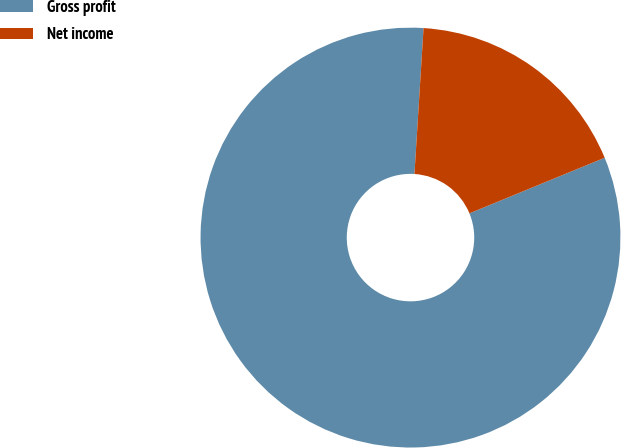Convert chart to OTSL. <chart><loc_0><loc_0><loc_500><loc_500><pie_chart><fcel>Gross profit<fcel>Net income<nl><fcel>82.2%<fcel>17.8%<nl></chart> 